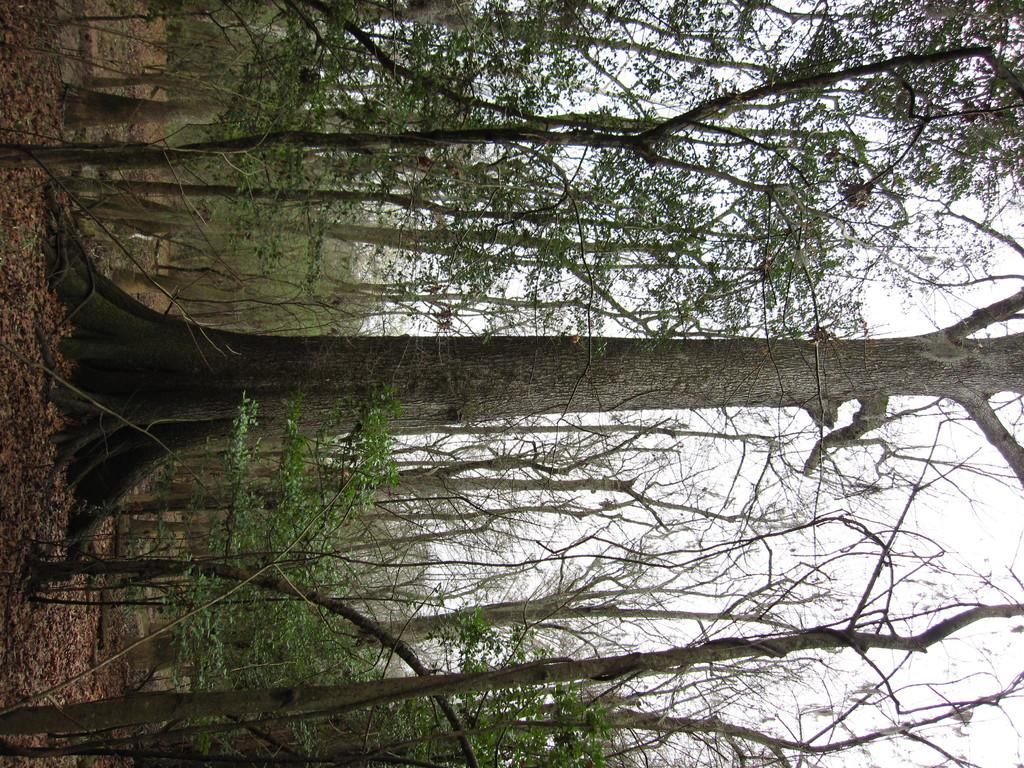What type of vegetation can be seen in the image? There are trees in the image. What is on the ground beneath the trees? There are leaves on the ground in the image. What can be seen in the distance in the image? The sky is visible in the background of the image. How many oceans can be seen in the image? There are no oceans present in the image. What is the size of the trees in the image? The size of the trees cannot be determined from the image alone, as there is no reference point for comparison. 